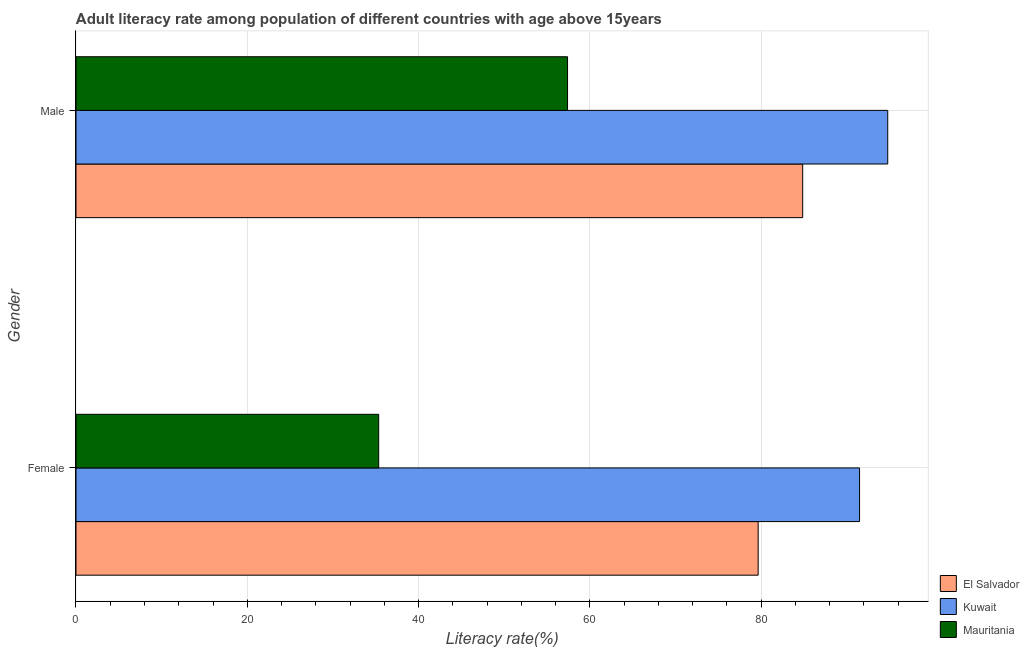How many different coloured bars are there?
Provide a succinct answer. 3. Are the number of bars per tick equal to the number of legend labels?
Your answer should be very brief. Yes. Are the number of bars on each tick of the Y-axis equal?
Offer a terse response. Yes. How many bars are there on the 2nd tick from the top?
Provide a short and direct response. 3. How many bars are there on the 1st tick from the bottom?
Your response must be concise. 3. What is the label of the 1st group of bars from the top?
Your answer should be very brief. Male. What is the female adult literacy rate in El Salvador?
Make the answer very short. 79.66. Across all countries, what is the maximum male adult literacy rate?
Your answer should be compact. 94.79. Across all countries, what is the minimum male adult literacy rate?
Keep it short and to the point. 57.4. In which country was the female adult literacy rate maximum?
Provide a short and direct response. Kuwait. In which country was the male adult literacy rate minimum?
Ensure brevity in your answer.  Mauritania. What is the total male adult literacy rate in the graph?
Your answer should be compact. 237.06. What is the difference between the male adult literacy rate in El Salvador and that in Kuwait?
Give a very brief answer. -9.93. What is the difference between the male adult literacy rate in Kuwait and the female adult literacy rate in Mauritania?
Your answer should be very brief. 59.45. What is the average female adult literacy rate per country?
Provide a short and direct response. 68.84. What is the difference between the male adult literacy rate and female adult literacy rate in El Salvador?
Ensure brevity in your answer.  5.2. In how many countries, is the female adult literacy rate greater than 44 %?
Provide a short and direct response. 2. What is the ratio of the female adult literacy rate in Mauritania to that in El Salvador?
Give a very brief answer. 0.44. Is the female adult literacy rate in Mauritania less than that in El Salvador?
Make the answer very short. Yes. In how many countries, is the female adult literacy rate greater than the average female adult literacy rate taken over all countries?
Offer a very short reply. 2. What does the 2nd bar from the top in Female represents?
Offer a very short reply. Kuwait. What does the 3rd bar from the bottom in Male represents?
Your response must be concise. Mauritania. How many bars are there?
Provide a succinct answer. 6. How many countries are there in the graph?
Keep it short and to the point. 3. Does the graph contain any zero values?
Ensure brevity in your answer.  No. Where does the legend appear in the graph?
Provide a succinct answer. Bottom right. What is the title of the graph?
Your response must be concise. Adult literacy rate among population of different countries with age above 15years. What is the label or title of the X-axis?
Provide a short and direct response. Literacy rate(%). What is the Literacy rate(%) in El Salvador in Female?
Your response must be concise. 79.66. What is the Literacy rate(%) of Kuwait in Female?
Offer a very short reply. 91.5. What is the Literacy rate(%) in Mauritania in Female?
Your answer should be compact. 35.35. What is the Literacy rate(%) in El Salvador in Male?
Offer a terse response. 84.86. What is the Literacy rate(%) of Kuwait in Male?
Offer a very short reply. 94.79. What is the Literacy rate(%) of Mauritania in Male?
Offer a terse response. 57.4. Across all Gender, what is the maximum Literacy rate(%) in El Salvador?
Provide a short and direct response. 84.86. Across all Gender, what is the maximum Literacy rate(%) in Kuwait?
Make the answer very short. 94.79. Across all Gender, what is the maximum Literacy rate(%) of Mauritania?
Give a very brief answer. 57.4. Across all Gender, what is the minimum Literacy rate(%) of El Salvador?
Offer a very short reply. 79.66. Across all Gender, what is the minimum Literacy rate(%) of Kuwait?
Provide a short and direct response. 91.5. Across all Gender, what is the minimum Literacy rate(%) of Mauritania?
Ensure brevity in your answer.  35.35. What is the total Literacy rate(%) in El Salvador in the graph?
Provide a short and direct response. 164.53. What is the total Literacy rate(%) of Kuwait in the graph?
Offer a very short reply. 186.3. What is the total Literacy rate(%) of Mauritania in the graph?
Keep it short and to the point. 92.75. What is the difference between the Literacy rate(%) of El Salvador in Female and that in Male?
Your answer should be compact. -5.2. What is the difference between the Literacy rate(%) in Kuwait in Female and that in Male?
Provide a succinct answer. -3.29. What is the difference between the Literacy rate(%) in Mauritania in Female and that in Male?
Provide a succinct answer. -22.06. What is the difference between the Literacy rate(%) in El Salvador in Female and the Literacy rate(%) in Kuwait in Male?
Make the answer very short. -15.13. What is the difference between the Literacy rate(%) of El Salvador in Female and the Literacy rate(%) of Mauritania in Male?
Offer a very short reply. 22.26. What is the difference between the Literacy rate(%) of Kuwait in Female and the Literacy rate(%) of Mauritania in Male?
Provide a short and direct response. 34.1. What is the average Literacy rate(%) of El Salvador per Gender?
Ensure brevity in your answer.  82.26. What is the average Literacy rate(%) of Kuwait per Gender?
Offer a very short reply. 93.15. What is the average Literacy rate(%) in Mauritania per Gender?
Give a very brief answer. 46.38. What is the difference between the Literacy rate(%) of El Salvador and Literacy rate(%) of Kuwait in Female?
Provide a short and direct response. -11.84. What is the difference between the Literacy rate(%) of El Salvador and Literacy rate(%) of Mauritania in Female?
Your answer should be compact. 44.31. What is the difference between the Literacy rate(%) in Kuwait and Literacy rate(%) in Mauritania in Female?
Ensure brevity in your answer.  56.16. What is the difference between the Literacy rate(%) of El Salvador and Literacy rate(%) of Kuwait in Male?
Offer a very short reply. -9.93. What is the difference between the Literacy rate(%) of El Salvador and Literacy rate(%) of Mauritania in Male?
Your answer should be compact. 27.46. What is the difference between the Literacy rate(%) of Kuwait and Literacy rate(%) of Mauritania in Male?
Provide a short and direct response. 37.39. What is the ratio of the Literacy rate(%) of El Salvador in Female to that in Male?
Offer a terse response. 0.94. What is the ratio of the Literacy rate(%) of Kuwait in Female to that in Male?
Give a very brief answer. 0.97. What is the ratio of the Literacy rate(%) in Mauritania in Female to that in Male?
Make the answer very short. 0.62. What is the difference between the highest and the second highest Literacy rate(%) in El Salvador?
Make the answer very short. 5.2. What is the difference between the highest and the second highest Literacy rate(%) of Kuwait?
Give a very brief answer. 3.29. What is the difference between the highest and the second highest Literacy rate(%) of Mauritania?
Give a very brief answer. 22.06. What is the difference between the highest and the lowest Literacy rate(%) of El Salvador?
Ensure brevity in your answer.  5.2. What is the difference between the highest and the lowest Literacy rate(%) of Kuwait?
Your answer should be very brief. 3.29. What is the difference between the highest and the lowest Literacy rate(%) of Mauritania?
Make the answer very short. 22.06. 